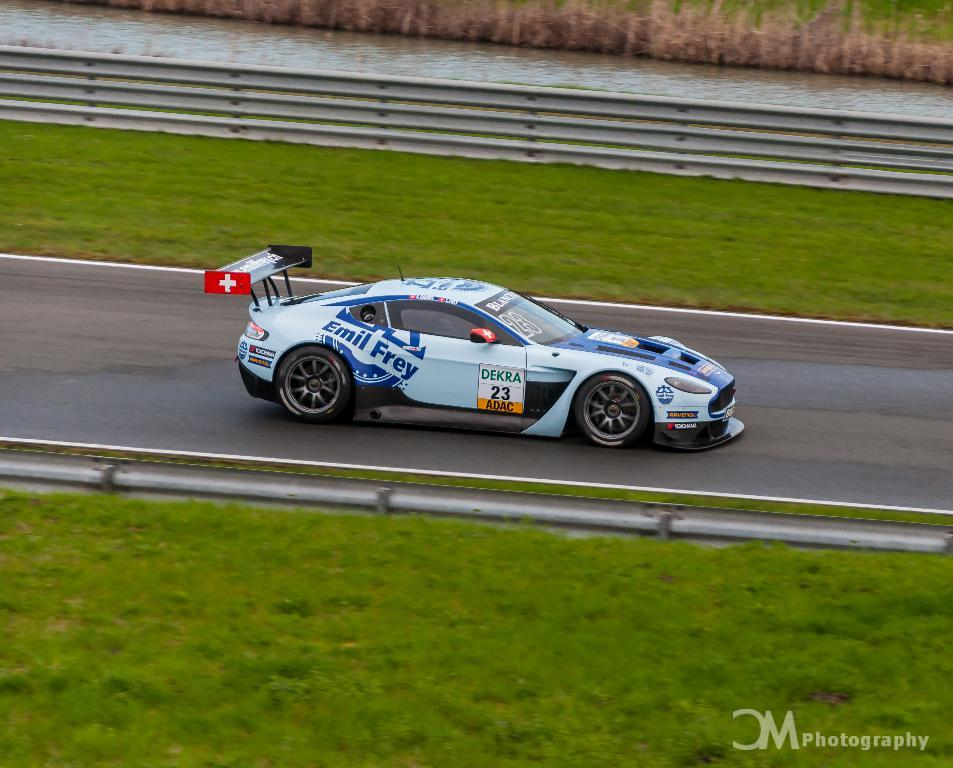What is the main subject in the center of the image? There is a car in the center of the image. What type of terrain is visible at the bottom of the image? There is grass and a road at the bottom of the image. What can be seen in the background of the image? There is a river, railing, and grass in the background of the image. What type of market is visible in the image? There is no market present in the image. Can you describe the kiss between the two people in the image? There are no people or kisses present in the image; it features a car, grass, a road, a river, railing, and grass in the background. 